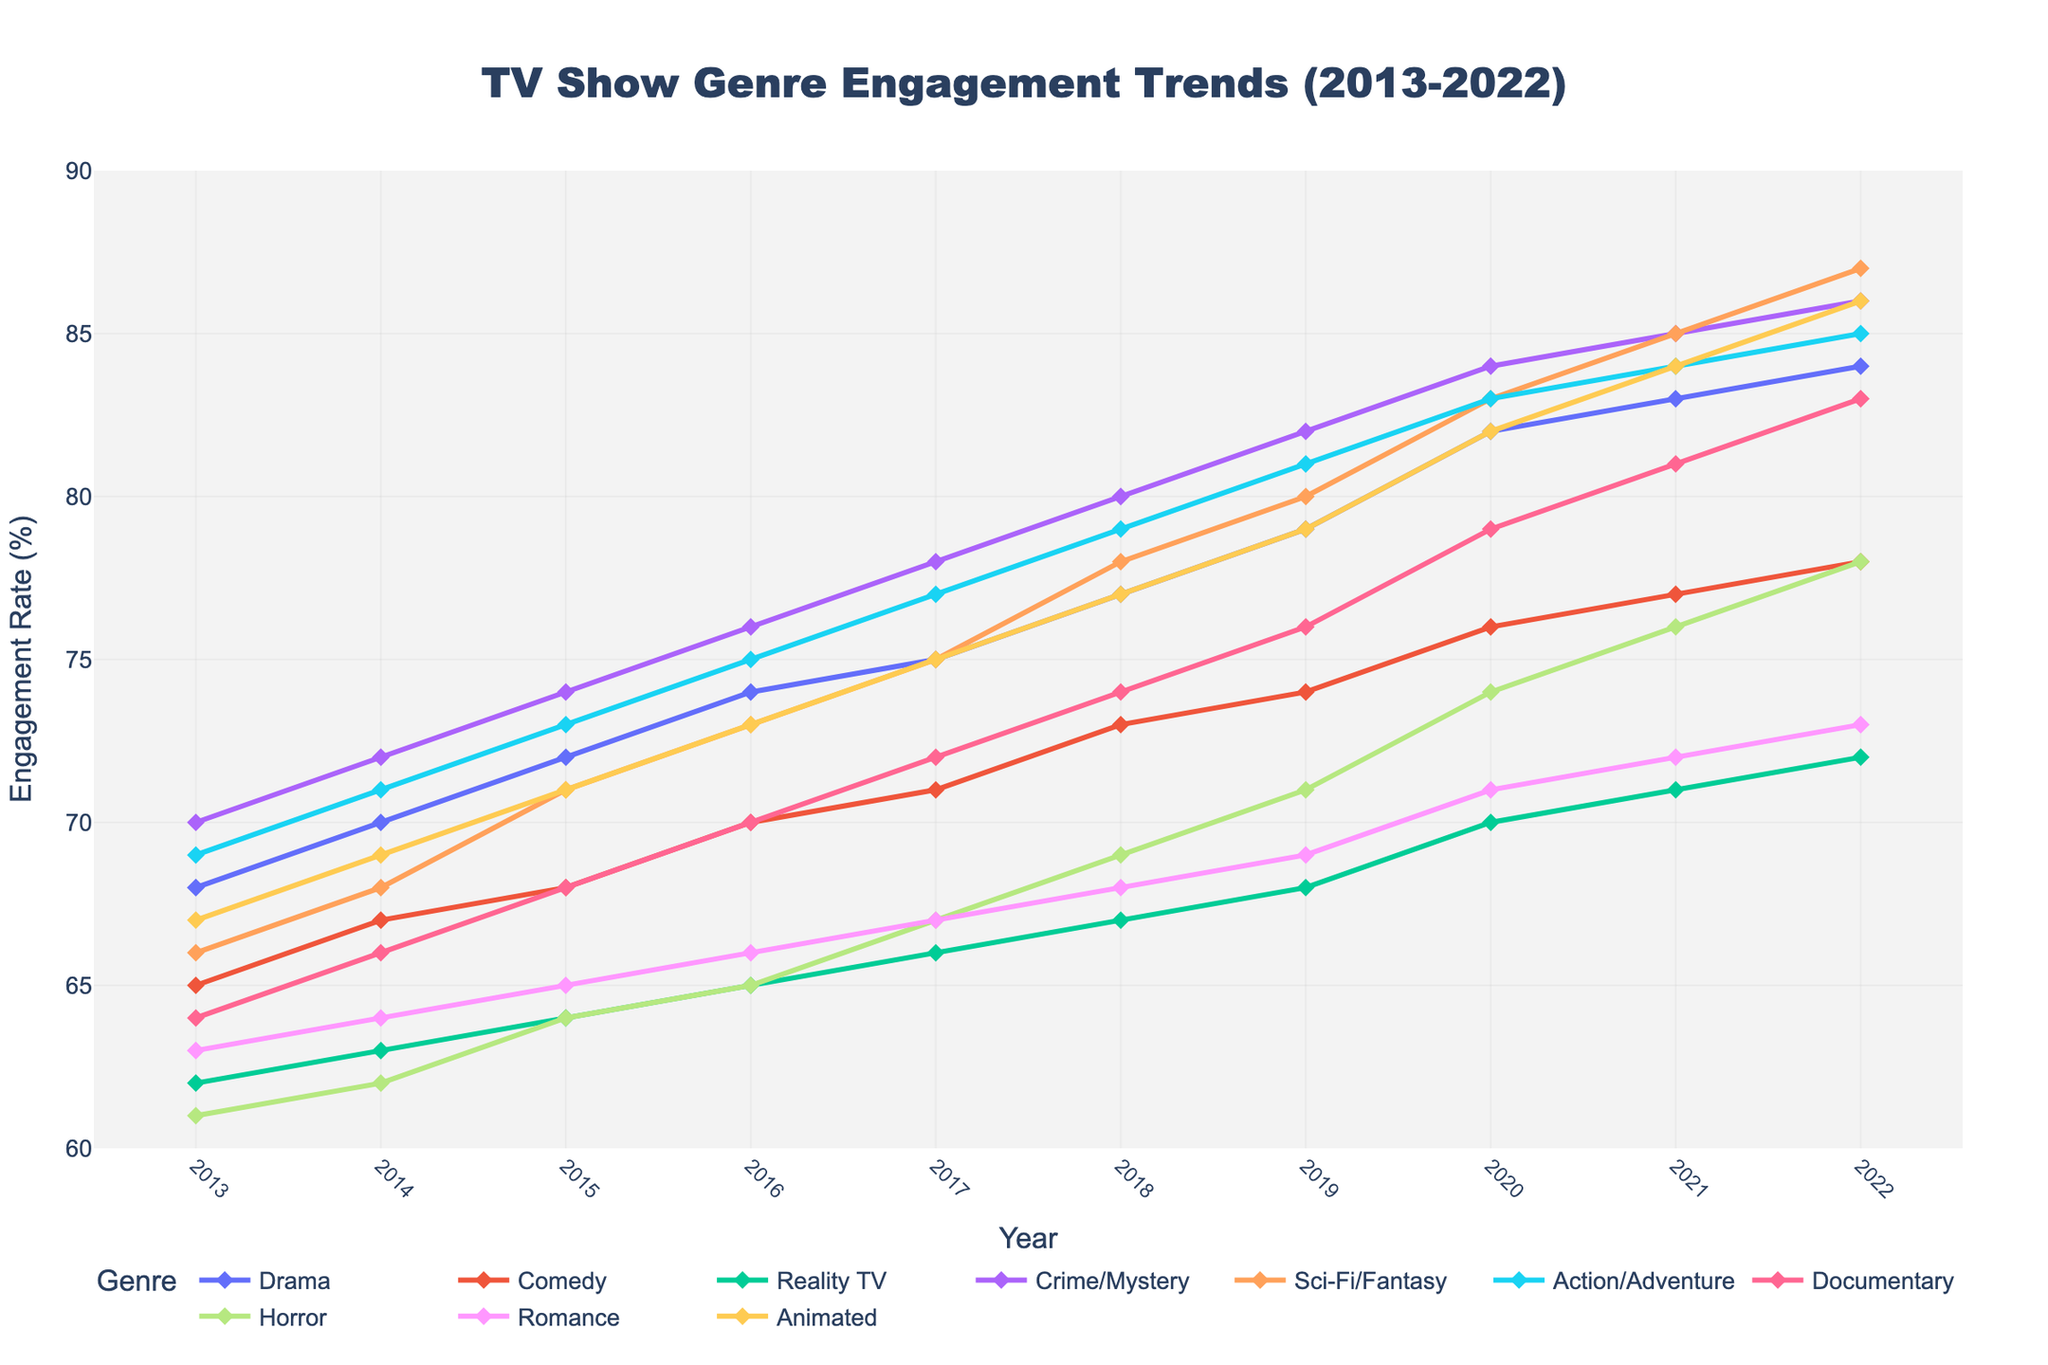What genre had the highest viewer engagement rate in 2022? The highest point on the y-axis in 2022 belongs to Sci-Fi/Fantasy, with a rate of 87%.
Answer: Sci-Fi/Fantasy Which genre showed the most significant increase in viewer engagement rate from 2013 to 2022? To find the most significant increase, we need to compute the difference between the values in 2022 and 2013 for each genre. The largest difference is for Sci-Fi/Fantasy (87 - 66 = 21%).
Answer: Sci-Fi/Fantasy How did the engagement rate for Drama change over the decade? By observing the trend line and recorded values for Drama from 2013 to 2022, the engagement rate increased consistently from 68% to 84%.
Answer: Increased from 68% to 84% Which two genres had the closest viewer engagement rates in 2015? Looking at 2015, Comedy and Animated both had an engagement rate of 71%.
Answer: Comedy and Animated In what year did Reality TV first surpass a viewer engagement rate of 70%? By examining the data points for Reality TV, we see that it first reached 70% in 2020.
Answer: 2020 What is the average engagement rate for Horror over the decade? Summing the engagement rates for Horror from 2013 to 2022 (61 + 62 + 64 + 65 + 67 + 69 + 71 + 74 + 76 + 78) and dividing by the number of years (10) gives 687/10 = 68.7%.
Answer: 68.7% Compare the viewer engagement trends for Documentary and Romance genres. Which genre showed a steeper increase? To determine which genre had a steeper increase, we calculate the difference over the decade: Documentary increased by 19% (83-64) and Romance increased by 10% (73-63).
Answer: Documentary What is the average viewer engagement rate across all genres in 2018? Summing the engagement rates for all ten genres in 2018 (77 + 73 + 67 + 80 + 78 + 79 + 74 + 69 + 68 + 77) yields 742; dividing by 10 gives an average of 74.2%.
Answer: 74.2% Which genre remained consistently below 80% in viewer engagement rates throughout the decade? By reviewing each genre's trend line, Romance consistently stayed below 80% from 2013 to 2022.
Answer: Romance Between Action/Adventure and Sci-Fi/Fantasy, which genre had a higher engagement rate in 2016, and by how much? In 2016, Sci-Fi/Fantasy had an engagement rate of 73%, while Action/Adventure was at 75%, making Action/Adventure higher by 2%.
Answer: Action/Adventure, by 2% 